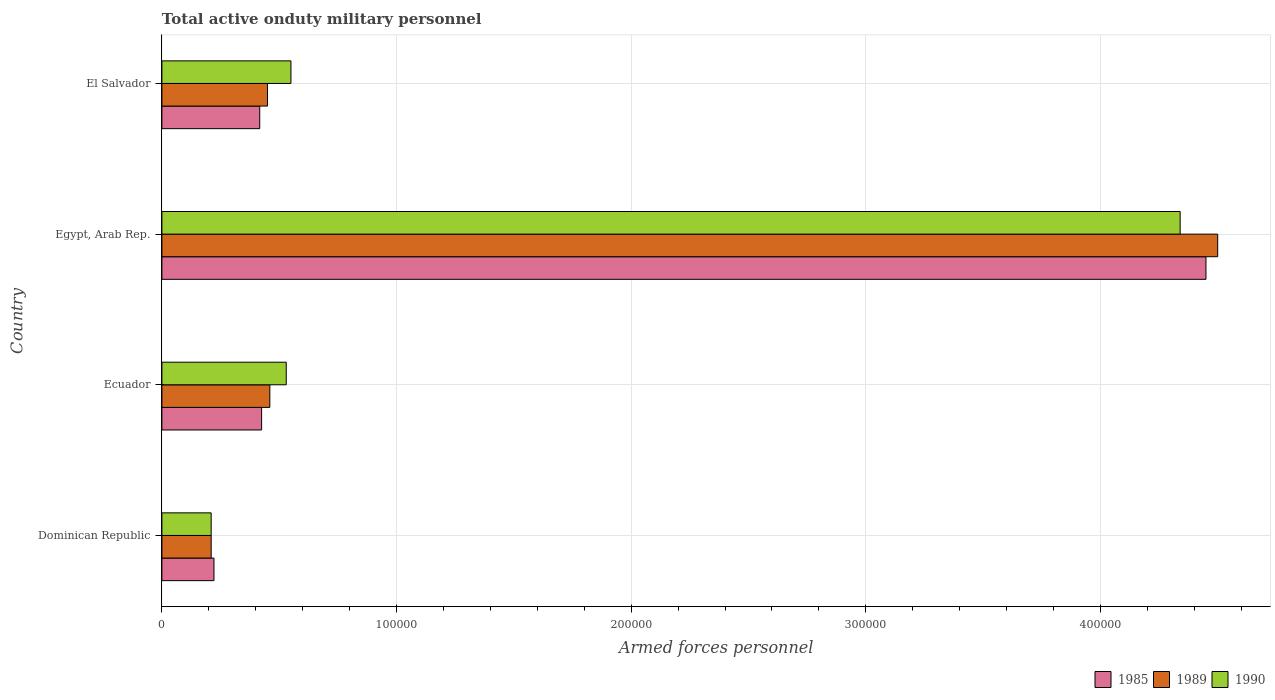How many groups of bars are there?
Keep it short and to the point. 4. Are the number of bars per tick equal to the number of legend labels?
Keep it short and to the point. Yes. Are the number of bars on each tick of the Y-axis equal?
Give a very brief answer. Yes. How many bars are there on the 3rd tick from the bottom?
Offer a terse response. 3. What is the label of the 2nd group of bars from the top?
Give a very brief answer. Egypt, Arab Rep. In how many cases, is the number of bars for a given country not equal to the number of legend labels?
Your answer should be very brief. 0. What is the number of armed forces personnel in 1990 in Egypt, Arab Rep.?
Offer a terse response. 4.34e+05. Across all countries, what is the maximum number of armed forces personnel in 1985?
Make the answer very short. 4.45e+05. Across all countries, what is the minimum number of armed forces personnel in 1989?
Your answer should be compact. 2.10e+04. In which country was the number of armed forces personnel in 1990 maximum?
Keep it short and to the point. Egypt, Arab Rep. In which country was the number of armed forces personnel in 1985 minimum?
Provide a short and direct response. Dominican Republic. What is the total number of armed forces personnel in 1985 in the graph?
Offer a terse response. 5.51e+05. What is the difference between the number of armed forces personnel in 1985 in Egypt, Arab Rep. and that in El Salvador?
Keep it short and to the point. 4.03e+05. What is the difference between the number of armed forces personnel in 1985 in Egypt, Arab Rep. and the number of armed forces personnel in 1990 in Ecuador?
Offer a very short reply. 3.92e+05. What is the average number of armed forces personnel in 1990 per country?
Your response must be concise. 1.41e+05. What is the ratio of the number of armed forces personnel in 1990 in Dominican Republic to that in Ecuador?
Ensure brevity in your answer.  0.4. What is the difference between the highest and the second highest number of armed forces personnel in 1985?
Give a very brief answer. 4.02e+05. What is the difference between the highest and the lowest number of armed forces personnel in 1989?
Offer a terse response. 4.29e+05. In how many countries, is the number of armed forces personnel in 1985 greater than the average number of armed forces personnel in 1985 taken over all countries?
Your answer should be compact. 1. Is the sum of the number of armed forces personnel in 1985 in Dominican Republic and Egypt, Arab Rep. greater than the maximum number of armed forces personnel in 1989 across all countries?
Provide a succinct answer. Yes. What does the 1st bar from the bottom in Ecuador represents?
Keep it short and to the point. 1985. How many bars are there?
Provide a short and direct response. 12. Are all the bars in the graph horizontal?
Offer a very short reply. Yes. How many countries are there in the graph?
Your answer should be very brief. 4. What is the difference between two consecutive major ticks on the X-axis?
Offer a very short reply. 1.00e+05. What is the title of the graph?
Make the answer very short. Total active onduty military personnel. Does "1972" appear as one of the legend labels in the graph?
Your answer should be compact. No. What is the label or title of the X-axis?
Offer a very short reply. Armed forces personnel. What is the Armed forces personnel in 1985 in Dominican Republic?
Your answer should be very brief. 2.22e+04. What is the Armed forces personnel in 1989 in Dominican Republic?
Give a very brief answer. 2.10e+04. What is the Armed forces personnel in 1990 in Dominican Republic?
Your response must be concise. 2.10e+04. What is the Armed forces personnel of 1985 in Ecuador?
Provide a short and direct response. 4.25e+04. What is the Armed forces personnel in 1989 in Ecuador?
Offer a very short reply. 4.60e+04. What is the Armed forces personnel of 1990 in Ecuador?
Provide a succinct answer. 5.30e+04. What is the Armed forces personnel in 1985 in Egypt, Arab Rep.?
Provide a succinct answer. 4.45e+05. What is the Armed forces personnel in 1990 in Egypt, Arab Rep.?
Make the answer very short. 4.34e+05. What is the Armed forces personnel in 1985 in El Salvador?
Your answer should be very brief. 4.17e+04. What is the Armed forces personnel in 1989 in El Salvador?
Your answer should be compact. 4.50e+04. What is the Armed forces personnel in 1990 in El Salvador?
Keep it short and to the point. 5.50e+04. Across all countries, what is the maximum Armed forces personnel in 1985?
Offer a very short reply. 4.45e+05. Across all countries, what is the maximum Armed forces personnel in 1990?
Provide a succinct answer. 4.34e+05. Across all countries, what is the minimum Armed forces personnel in 1985?
Your answer should be very brief. 2.22e+04. Across all countries, what is the minimum Armed forces personnel of 1989?
Provide a short and direct response. 2.10e+04. Across all countries, what is the minimum Armed forces personnel of 1990?
Offer a terse response. 2.10e+04. What is the total Armed forces personnel of 1985 in the graph?
Provide a succinct answer. 5.51e+05. What is the total Armed forces personnel in 1989 in the graph?
Keep it short and to the point. 5.62e+05. What is the total Armed forces personnel of 1990 in the graph?
Give a very brief answer. 5.63e+05. What is the difference between the Armed forces personnel in 1985 in Dominican Republic and that in Ecuador?
Give a very brief answer. -2.03e+04. What is the difference between the Armed forces personnel of 1989 in Dominican Republic and that in Ecuador?
Provide a succinct answer. -2.50e+04. What is the difference between the Armed forces personnel of 1990 in Dominican Republic and that in Ecuador?
Ensure brevity in your answer.  -3.20e+04. What is the difference between the Armed forces personnel of 1985 in Dominican Republic and that in Egypt, Arab Rep.?
Make the answer very short. -4.23e+05. What is the difference between the Armed forces personnel of 1989 in Dominican Republic and that in Egypt, Arab Rep.?
Make the answer very short. -4.29e+05. What is the difference between the Armed forces personnel of 1990 in Dominican Republic and that in Egypt, Arab Rep.?
Provide a succinct answer. -4.13e+05. What is the difference between the Armed forces personnel of 1985 in Dominican Republic and that in El Salvador?
Keep it short and to the point. -1.95e+04. What is the difference between the Armed forces personnel in 1989 in Dominican Republic and that in El Salvador?
Give a very brief answer. -2.40e+04. What is the difference between the Armed forces personnel in 1990 in Dominican Republic and that in El Salvador?
Provide a short and direct response. -3.40e+04. What is the difference between the Armed forces personnel of 1985 in Ecuador and that in Egypt, Arab Rep.?
Offer a terse response. -4.02e+05. What is the difference between the Armed forces personnel of 1989 in Ecuador and that in Egypt, Arab Rep.?
Provide a short and direct response. -4.04e+05. What is the difference between the Armed forces personnel in 1990 in Ecuador and that in Egypt, Arab Rep.?
Your response must be concise. -3.81e+05. What is the difference between the Armed forces personnel in 1985 in Ecuador and that in El Salvador?
Keep it short and to the point. 800. What is the difference between the Armed forces personnel of 1989 in Ecuador and that in El Salvador?
Your response must be concise. 1000. What is the difference between the Armed forces personnel in 1990 in Ecuador and that in El Salvador?
Keep it short and to the point. -2000. What is the difference between the Armed forces personnel of 1985 in Egypt, Arab Rep. and that in El Salvador?
Keep it short and to the point. 4.03e+05. What is the difference between the Armed forces personnel in 1989 in Egypt, Arab Rep. and that in El Salvador?
Give a very brief answer. 4.05e+05. What is the difference between the Armed forces personnel of 1990 in Egypt, Arab Rep. and that in El Salvador?
Ensure brevity in your answer.  3.79e+05. What is the difference between the Armed forces personnel of 1985 in Dominican Republic and the Armed forces personnel of 1989 in Ecuador?
Provide a succinct answer. -2.38e+04. What is the difference between the Armed forces personnel in 1985 in Dominican Republic and the Armed forces personnel in 1990 in Ecuador?
Your answer should be very brief. -3.08e+04. What is the difference between the Armed forces personnel in 1989 in Dominican Republic and the Armed forces personnel in 1990 in Ecuador?
Offer a very short reply. -3.20e+04. What is the difference between the Armed forces personnel of 1985 in Dominican Republic and the Armed forces personnel of 1989 in Egypt, Arab Rep.?
Provide a succinct answer. -4.28e+05. What is the difference between the Armed forces personnel of 1985 in Dominican Republic and the Armed forces personnel of 1990 in Egypt, Arab Rep.?
Your answer should be compact. -4.12e+05. What is the difference between the Armed forces personnel of 1989 in Dominican Republic and the Armed forces personnel of 1990 in Egypt, Arab Rep.?
Your answer should be very brief. -4.13e+05. What is the difference between the Armed forces personnel in 1985 in Dominican Republic and the Armed forces personnel in 1989 in El Salvador?
Offer a terse response. -2.28e+04. What is the difference between the Armed forces personnel of 1985 in Dominican Republic and the Armed forces personnel of 1990 in El Salvador?
Ensure brevity in your answer.  -3.28e+04. What is the difference between the Armed forces personnel of 1989 in Dominican Republic and the Armed forces personnel of 1990 in El Salvador?
Give a very brief answer. -3.40e+04. What is the difference between the Armed forces personnel of 1985 in Ecuador and the Armed forces personnel of 1989 in Egypt, Arab Rep.?
Offer a very short reply. -4.08e+05. What is the difference between the Armed forces personnel of 1985 in Ecuador and the Armed forces personnel of 1990 in Egypt, Arab Rep.?
Ensure brevity in your answer.  -3.92e+05. What is the difference between the Armed forces personnel in 1989 in Ecuador and the Armed forces personnel in 1990 in Egypt, Arab Rep.?
Offer a terse response. -3.88e+05. What is the difference between the Armed forces personnel in 1985 in Ecuador and the Armed forces personnel in 1989 in El Salvador?
Offer a terse response. -2500. What is the difference between the Armed forces personnel of 1985 in Ecuador and the Armed forces personnel of 1990 in El Salvador?
Your response must be concise. -1.25e+04. What is the difference between the Armed forces personnel of 1989 in Ecuador and the Armed forces personnel of 1990 in El Salvador?
Your response must be concise. -9000. What is the difference between the Armed forces personnel in 1985 in Egypt, Arab Rep. and the Armed forces personnel in 1989 in El Salvador?
Your answer should be very brief. 4.00e+05. What is the difference between the Armed forces personnel in 1985 in Egypt, Arab Rep. and the Armed forces personnel in 1990 in El Salvador?
Offer a very short reply. 3.90e+05. What is the difference between the Armed forces personnel in 1989 in Egypt, Arab Rep. and the Armed forces personnel in 1990 in El Salvador?
Give a very brief answer. 3.95e+05. What is the average Armed forces personnel of 1985 per country?
Provide a succinct answer. 1.38e+05. What is the average Armed forces personnel of 1989 per country?
Your answer should be very brief. 1.40e+05. What is the average Armed forces personnel of 1990 per country?
Keep it short and to the point. 1.41e+05. What is the difference between the Armed forces personnel in 1985 and Armed forces personnel in 1989 in Dominican Republic?
Ensure brevity in your answer.  1200. What is the difference between the Armed forces personnel in 1985 and Armed forces personnel in 1990 in Dominican Republic?
Your answer should be very brief. 1200. What is the difference between the Armed forces personnel of 1985 and Armed forces personnel of 1989 in Ecuador?
Provide a succinct answer. -3500. What is the difference between the Armed forces personnel in 1985 and Armed forces personnel in 1990 in Ecuador?
Make the answer very short. -1.05e+04. What is the difference between the Armed forces personnel in 1989 and Armed forces personnel in 1990 in Ecuador?
Make the answer very short. -7000. What is the difference between the Armed forces personnel in 1985 and Armed forces personnel in 1989 in Egypt, Arab Rep.?
Ensure brevity in your answer.  -5000. What is the difference between the Armed forces personnel in 1985 and Armed forces personnel in 1990 in Egypt, Arab Rep.?
Offer a terse response. 1.10e+04. What is the difference between the Armed forces personnel in 1989 and Armed forces personnel in 1990 in Egypt, Arab Rep.?
Offer a very short reply. 1.60e+04. What is the difference between the Armed forces personnel of 1985 and Armed forces personnel of 1989 in El Salvador?
Provide a succinct answer. -3300. What is the difference between the Armed forces personnel of 1985 and Armed forces personnel of 1990 in El Salvador?
Give a very brief answer. -1.33e+04. What is the ratio of the Armed forces personnel in 1985 in Dominican Republic to that in Ecuador?
Provide a succinct answer. 0.52. What is the ratio of the Armed forces personnel in 1989 in Dominican Republic to that in Ecuador?
Provide a succinct answer. 0.46. What is the ratio of the Armed forces personnel in 1990 in Dominican Republic to that in Ecuador?
Your answer should be compact. 0.4. What is the ratio of the Armed forces personnel of 1985 in Dominican Republic to that in Egypt, Arab Rep.?
Your response must be concise. 0.05. What is the ratio of the Armed forces personnel of 1989 in Dominican Republic to that in Egypt, Arab Rep.?
Your answer should be compact. 0.05. What is the ratio of the Armed forces personnel of 1990 in Dominican Republic to that in Egypt, Arab Rep.?
Offer a very short reply. 0.05. What is the ratio of the Armed forces personnel of 1985 in Dominican Republic to that in El Salvador?
Your answer should be very brief. 0.53. What is the ratio of the Armed forces personnel in 1989 in Dominican Republic to that in El Salvador?
Your response must be concise. 0.47. What is the ratio of the Armed forces personnel in 1990 in Dominican Republic to that in El Salvador?
Your answer should be compact. 0.38. What is the ratio of the Armed forces personnel in 1985 in Ecuador to that in Egypt, Arab Rep.?
Give a very brief answer. 0.1. What is the ratio of the Armed forces personnel in 1989 in Ecuador to that in Egypt, Arab Rep.?
Ensure brevity in your answer.  0.1. What is the ratio of the Armed forces personnel of 1990 in Ecuador to that in Egypt, Arab Rep.?
Give a very brief answer. 0.12. What is the ratio of the Armed forces personnel of 1985 in Ecuador to that in El Salvador?
Offer a very short reply. 1.02. What is the ratio of the Armed forces personnel of 1989 in Ecuador to that in El Salvador?
Your answer should be very brief. 1.02. What is the ratio of the Armed forces personnel in 1990 in Ecuador to that in El Salvador?
Ensure brevity in your answer.  0.96. What is the ratio of the Armed forces personnel of 1985 in Egypt, Arab Rep. to that in El Salvador?
Your response must be concise. 10.67. What is the ratio of the Armed forces personnel of 1989 in Egypt, Arab Rep. to that in El Salvador?
Your response must be concise. 10. What is the ratio of the Armed forces personnel of 1990 in Egypt, Arab Rep. to that in El Salvador?
Your answer should be compact. 7.89. What is the difference between the highest and the second highest Armed forces personnel in 1985?
Your response must be concise. 4.02e+05. What is the difference between the highest and the second highest Armed forces personnel of 1989?
Give a very brief answer. 4.04e+05. What is the difference between the highest and the second highest Armed forces personnel in 1990?
Make the answer very short. 3.79e+05. What is the difference between the highest and the lowest Armed forces personnel of 1985?
Provide a short and direct response. 4.23e+05. What is the difference between the highest and the lowest Armed forces personnel of 1989?
Your answer should be compact. 4.29e+05. What is the difference between the highest and the lowest Armed forces personnel in 1990?
Give a very brief answer. 4.13e+05. 